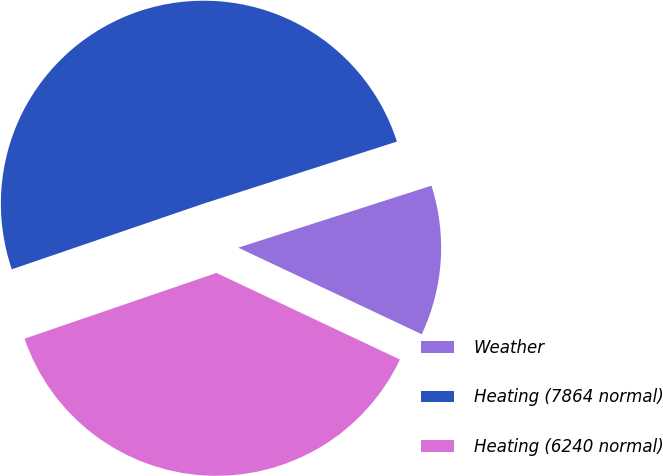Convert chart to OTSL. <chart><loc_0><loc_0><loc_500><loc_500><pie_chart><fcel>Weather<fcel>Heating (7864 normal)<fcel>Heating (6240 normal)<nl><fcel>11.96%<fcel>50.31%<fcel>37.73%<nl></chart> 